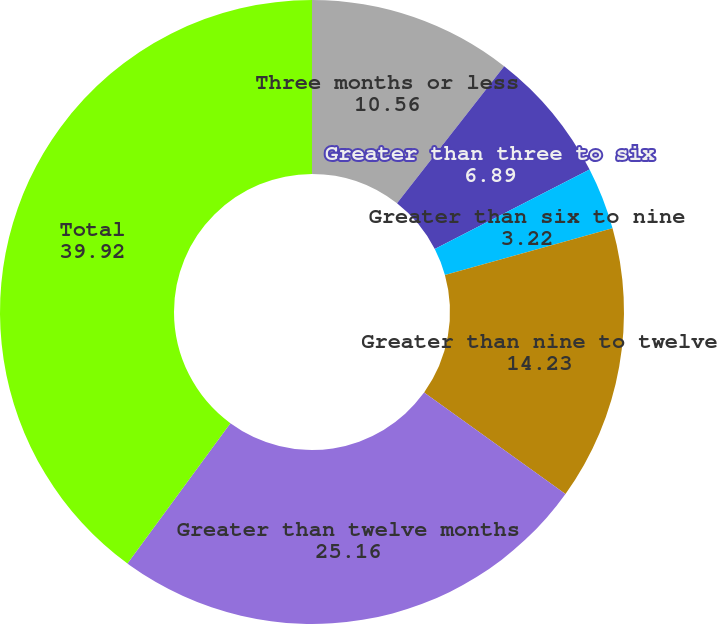Convert chart. <chart><loc_0><loc_0><loc_500><loc_500><pie_chart><fcel>Three months or less<fcel>Greater than three to six<fcel>Greater than six to nine<fcel>Greater than nine to twelve<fcel>Greater than twelve months<fcel>Total<nl><fcel>10.56%<fcel>6.89%<fcel>3.22%<fcel>14.23%<fcel>25.16%<fcel>39.92%<nl></chart> 